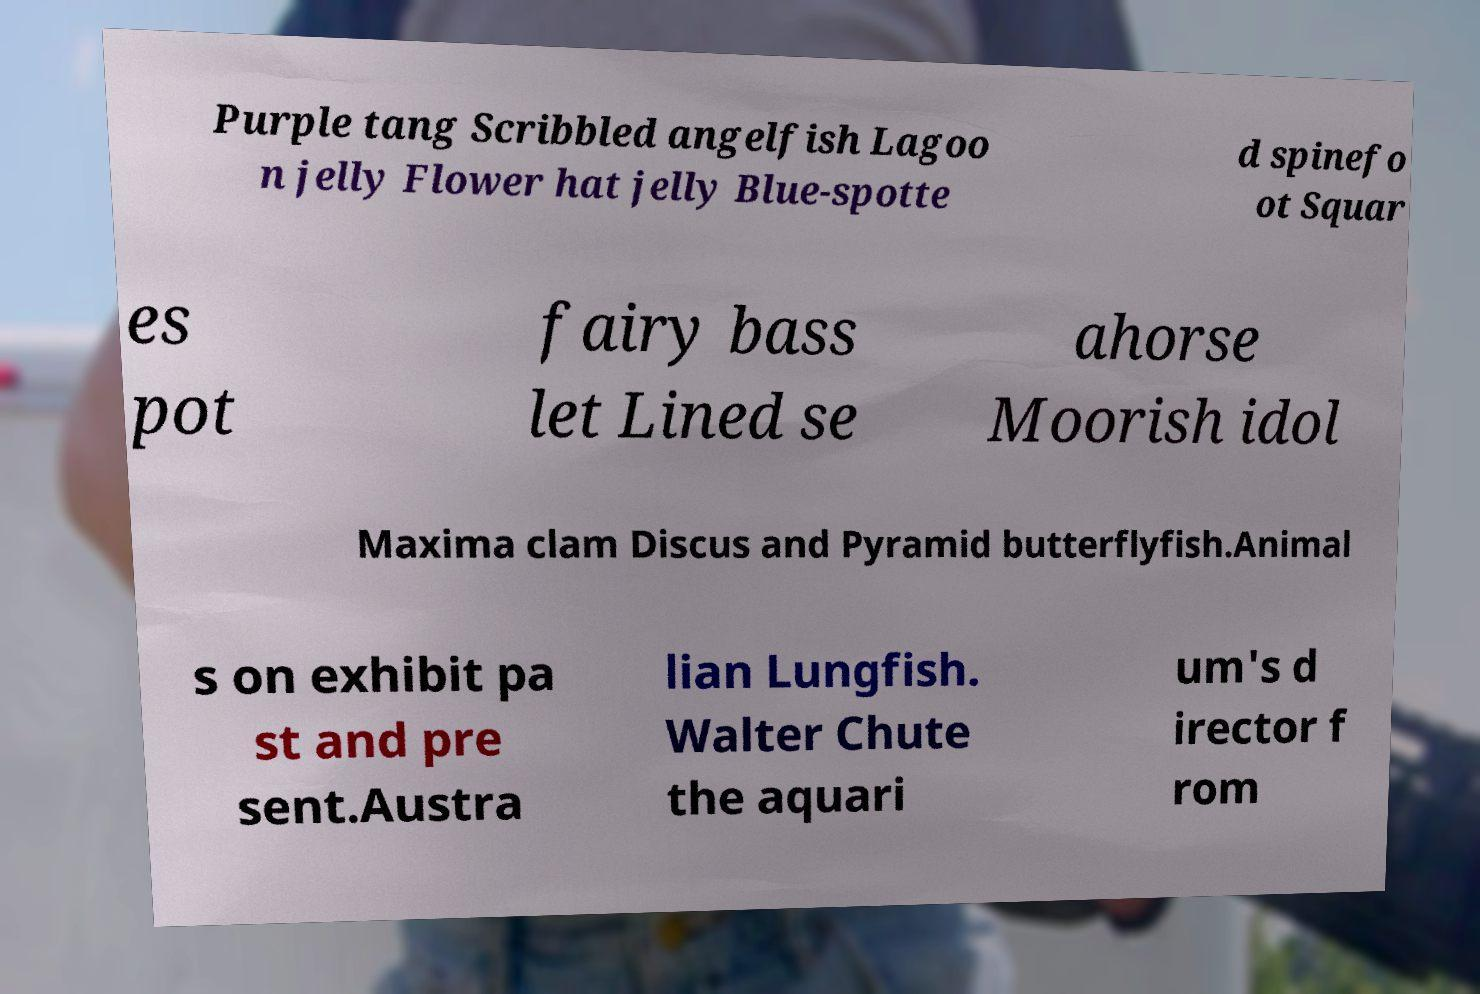For documentation purposes, I need the text within this image transcribed. Could you provide that? Purple tang Scribbled angelfish Lagoo n jelly Flower hat jelly Blue-spotte d spinefo ot Squar es pot fairy bass let Lined se ahorse Moorish idol Maxima clam Discus and Pyramid butterflyfish.Animal s on exhibit pa st and pre sent.Austra lian Lungfish. Walter Chute the aquari um's d irector f rom 